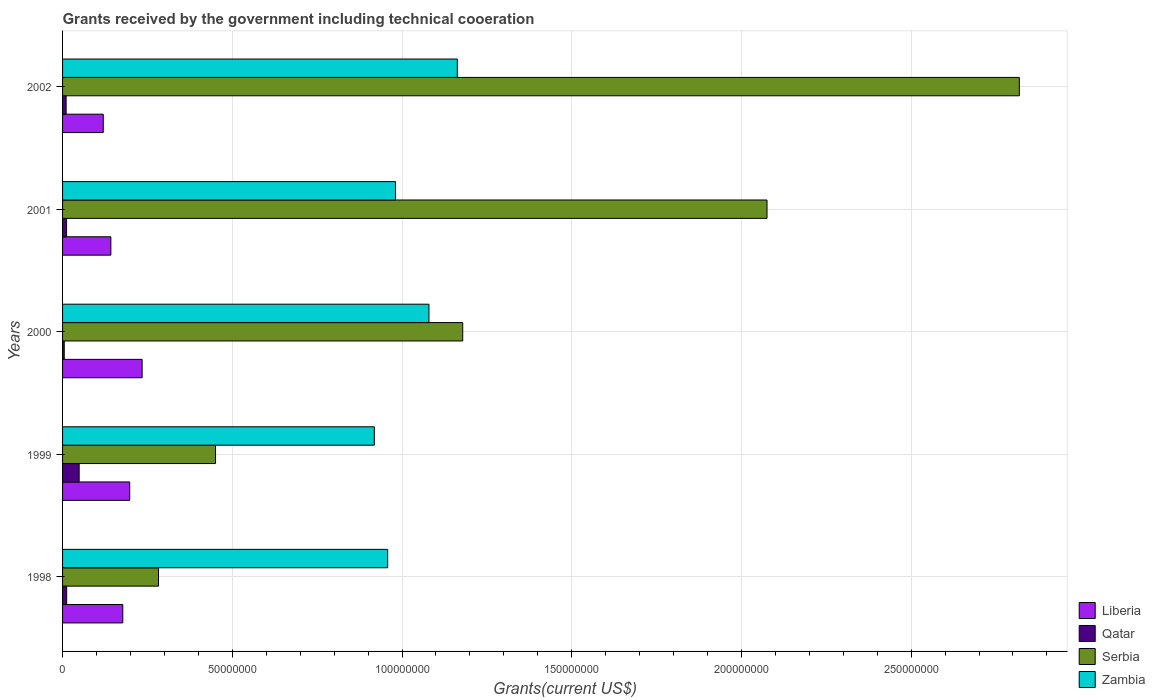How many groups of bars are there?
Your answer should be very brief. 5. Are the number of bars per tick equal to the number of legend labels?
Provide a short and direct response. Yes. How many bars are there on the 3rd tick from the top?
Offer a terse response. 4. How many bars are there on the 1st tick from the bottom?
Make the answer very short. 4. In how many cases, is the number of bars for a given year not equal to the number of legend labels?
Make the answer very short. 0. What is the total grants received by the government in Qatar in 1998?
Keep it short and to the point. 1.21e+06. Across all years, what is the maximum total grants received by the government in Qatar?
Make the answer very short. 4.89e+06. Across all years, what is the minimum total grants received by the government in Serbia?
Keep it short and to the point. 2.83e+07. In which year was the total grants received by the government in Zambia maximum?
Your answer should be compact. 2002. What is the total total grants received by the government in Serbia in the graph?
Keep it short and to the point. 6.81e+08. What is the difference between the total grants received by the government in Serbia in 1998 and that in 2002?
Ensure brevity in your answer.  -2.54e+08. What is the difference between the total grants received by the government in Qatar in 2001 and the total grants received by the government in Liberia in 2002?
Keep it short and to the point. -1.08e+07. What is the average total grants received by the government in Qatar per year?
Give a very brief answer. 1.76e+06. In the year 2000, what is the difference between the total grants received by the government in Serbia and total grants received by the government in Zambia?
Your response must be concise. 9.95e+06. In how many years, is the total grants received by the government in Zambia greater than 250000000 US$?
Offer a very short reply. 0. What is the ratio of the total grants received by the government in Qatar in 1998 to that in 2001?
Your answer should be compact. 1.03. Is the difference between the total grants received by the government in Serbia in 1999 and 2000 greater than the difference between the total grants received by the government in Zambia in 1999 and 2000?
Offer a terse response. No. What is the difference between the highest and the second highest total grants received by the government in Zambia?
Keep it short and to the point. 8.36e+06. What is the difference between the highest and the lowest total grants received by the government in Qatar?
Ensure brevity in your answer.  4.40e+06. Is it the case that in every year, the sum of the total grants received by the government in Qatar and total grants received by the government in Zambia is greater than the sum of total grants received by the government in Serbia and total grants received by the government in Liberia?
Ensure brevity in your answer.  No. What does the 3rd bar from the top in 1999 represents?
Provide a succinct answer. Qatar. What does the 2nd bar from the bottom in 2000 represents?
Make the answer very short. Qatar. How many bars are there?
Your answer should be compact. 20. How many years are there in the graph?
Your answer should be compact. 5. Are the values on the major ticks of X-axis written in scientific E-notation?
Make the answer very short. No. Does the graph contain grids?
Your answer should be very brief. Yes. Where does the legend appear in the graph?
Keep it short and to the point. Bottom right. How are the legend labels stacked?
Ensure brevity in your answer.  Vertical. What is the title of the graph?
Your answer should be very brief. Grants received by the government including technical cooeration. Does "Kazakhstan" appear as one of the legend labels in the graph?
Keep it short and to the point. No. What is the label or title of the X-axis?
Give a very brief answer. Grants(current US$). What is the Grants(current US$) of Liberia in 1998?
Provide a short and direct response. 1.77e+07. What is the Grants(current US$) in Qatar in 1998?
Keep it short and to the point. 1.21e+06. What is the Grants(current US$) in Serbia in 1998?
Offer a terse response. 2.83e+07. What is the Grants(current US$) in Zambia in 1998?
Offer a terse response. 9.58e+07. What is the Grants(current US$) in Liberia in 1999?
Your response must be concise. 1.98e+07. What is the Grants(current US$) in Qatar in 1999?
Your answer should be compact. 4.89e+06. What is the Grants(current US$) in Serbia in 1999?
Give a very brief answer. 4.51e+07. What is the Grants(current US$) in Zambia in 1999?
Give a very brief answer. 9.18e+07. What is the Grants(current US$) of Liberia in 2000?
Make the answer very short. 2.34e+07. What is the Grants(current US$) in Qatar in 2000?
Provide a succinct answer. 4.90e+05. What is the Grants(current US$) in Serbia in 2000?
Your response must be concise. 1.18e+08. What is the Grants(current US$) in Zambia in 2000?
Offer a terse response. 1.08e+08. What is the Grants(current US$) of Liberia in 2001?
Offer a terse response. 1.42e+07. What is the Grants(current US$) of Qatar in 2001?
Make the answer very short. 1.18e+06. What is the Grants(current US$) of Serbia in 2001?
Provide a short and direct response. 2.08e+08. What is the Grants(current US$) of Zambia in 2001?
Give a very brief answer. 9.81e+07. What is the Grants(current US$) in Liberia in 2002?
Ensure brevity in your answer.  1.20e+07. What is the Grants(current US$) in Qatar in 2002?
Offer a terse response. 1.05e+06. What is the Grants(current US$) in Serbia in 2002?
Your answer should be very brief. 2.82e+08. What is the Grants(current US$) of Zambia in 2002?
Your response must be concise. 1.16e+08. Across all years, what is the maximum Grants(current US$) in Liberia?
Provide a succinct answer. 2.34e+07. Across all years, what is the maximum Grants(current US$) in Qatar?
Provide a short and direct response. 4.89e+06. Across all years, what is the maximum Grants(current US$) in Serbia?
Your answer should be very brief. 2.82e+08. Across all years, what is the maximum Grants(current US$) in Zambia?
Your answer should be very brief. 1.16e+08. Across all years, what is the minimum Grants(current US$) of Liberia?
Provide a short and direct response. 1.20e+07. Across all years, what is the minimum Grants(current US$) of Serbia?
Provide a succinct answer. 2.83e+07. Across all years, what is the minimum Grants(current US$) in Zambia?
Give a very brief answer. 9.18e+07. What is the total Grants(current US$) in Liberia in the graph?
Offer a very short reply. 8.72e+07. What is the total Grants(current US$) in Qatar in the graph?
Give a very brief answer. 8.82e+06. What is the total Grants(current US$) in Serbia in the graph?
Offer a very short reply. 6.81e+08. What is the total Grants(current US$) in Zambia in the graph?
Keep it short and to the point. 5.10e+08. What is the difference between the Grants(current US$) of Liberia in 1998 and that in 1999?
Provide a short and direct response. -2.04e+06. What is the difference between the Grants(current US$) of Qatar in 1998 and that in 1999?
Provide a short and direct response. -3.68e+06. What is the difference between the Grants(current US$) in Serbia in 1998 and that in 1999?
Make the answer very short. -1.68e+07. What is the difference between the Grants(current US$) of Zambia in 1998 and that in 1999?
Give a very brief answer. 3.93e+06. What is the difference between the Grants(current US$) in Liberia in 1998 and that in 2000?
Make the answer very short. -5.70e+06. What is the difference between the Grants(current US$) in Qatar in 1998 and that in 2000?
Ensure brevity in your answer.  7.20e+05. What is the difference between the Grants(current US$) of Serbia in 1998 and that in 2000?
Offer a very short reply. -8.96e+07. What is the difference between the Grants(current US$) of Zambia in 1998 and that in 2000?
Your response must be concise. -1.22e+07. What is the difference between the Grants(current US$) in Liberia in 1998 and that in 2001?
Keep it short and to the point. 3.51e+06. What is the difference between the Grants(current US$) in Serbia in 1998 and that in 2001?
Offer a very short reply. -1.79e+08. What is the difference between the Grants(current US$) in Zambia in 1998 and that in 2001?
Ensure brevity in your answer.  -2.31e+06. What is the difference between the Grants(current US$) in Liberia in 1998 and that in 2002?
Provide a short and direct response. 5.75e+06. What is the difference between the Grants(current US$) of Qatar in 1998 and that in 2002?
Give a very brief answer. 1.60e+05. What is the difference between the Grants(current US$) of Serbia in 1998 and that in 2002?
Your answer should be very brief. -2.54e+08. What is the difference between the Grants(current US$) in Zambia in 1998 and that in 2002?
Provide a short and direct response. -2.05e+07. What is the difference between the Grants(current US$) in Liberia in 1999 and that in 2000?
Your answer should be compact. -3.66e+06. What is the difference between the Grants(current US$) of Qatar in 1999 and that in 2000?
Provide a succinct answer. 4.40e+06. What is the difference between the Grants(current US$) of Serbia in 1999 and that in 2000?
Keep it short and to the point. -7.28e+07. What is the difference between the Grants(current US$) in Zambia in 1999 and that in 2000?
Offer a very short reply. -1.61e+07. What is the difference between the Grants(current US$) of Liberia in 1999 and that in 2001?
Keep it short and to the point. 5.55e+06. What is the difference between the Grants(current US$) of Qatar in 1999 and that in 2001?
Make the answer very short. 3.71e+06. What is the difference between the Grants(current US$) in Serbia in 1999 and that in 2001?
Provide a succinct answer. -1.62e+08. What is the difference between the Grants(current US$) in Zambia in 1999 and that in 2001?
Your response must be concise. -6.24e+06. What is the difference between the Grants(current US$) of Liberia in 1999 and that in 2002?
Provide a short and direct response. 7.79e+06. What is the difference between the Grants(current US$) of Qatar in 1999 and that in 2002?
Keep it short and to the point. 3.84e+06. What is the difference between the Grants(current US$) of Serbia in 1999 and that in 2002?
Your answer should be very brief. -2.37e+08. What is the difference between the Grants(current US$) of Zambia in 1999 and that in 2002?
Offer a very short reply. -2.44e+07. What is the difference between the Grants(current US$) in Liberia in 2000 and that in 2001?
Give a very brief answer. 9.21e+06. What is the difference between the Grants(current US$) of Qatar in 2000 and that in 2001?
Provide a short and direct response. -6.90e+05. What is the difference between the Grants(current US$) of Serbia in 2000 and that in 2001?
Ensure brevity in your answer.  -8.96e+07. What is the difference between the Grants(current US$) of Zambia in 2000 and that in 2001?
Offer a very short reply. 9.85e+06. What is the difference between the Grants(current US$) of Liberia in 2000 and that in 2002?
Provide a short and direct response. 1.14e+07. What is the difference between the Grants(current US$) of Qatar in 2000 and that in 2002?
Make the answer very short. -5.60e+05. What is the difference between the Grants(current US$) of Serbia in 2000 and that in 2002?
Provide a short and direct response. -1.64e+08. What is the difference between the Grants(current US$) in Zambia in 2000 and that in 2002?
Ensure brevity in your answer.  -8.36e+06. What is the difference between the Grants(current US$) of Liberia in 2001 and that in 2002?
Keep it short and to the point. 2.24e+06. What is the difference between the Grants(current US$) of Serbia in 2001 and that in 2002?
Offer a terse response. -7.43e+07. What is the difference between the Grants(current US$) of Zambia in 2001 and that in 2002?
Offer a terse response. -1.82e+07. What is the difference between the Grants(current US$) of Liberia in 1998 and the Grants(current US$) of Qatar in 1999?
Offer a terse response. 1.28e+07. What is the difference between the Grants(current US$) of Liberia in 1998 and the Grants(current US$) of Serbia in 1999?
Provide a short and direct response. -2.73e+07. What is the difference between the Grants(current US$) of Liberia in 1998 and the Grants(current US$) of Zambia in 1999?
Your answer should be very brief. -7.41e+07. What is the difference between the Grants(current US$) of Qatar in 1998 and the Grants(current US$) of Serbia in 1999?
Make the answer very short. -4.39e+07. What is the difference between the Grants(current US$) of Qatar in 1998 and the Grants(current US$) of Zambia in 1999?
Provide a short and direct response. -9.06e+07. What is the difference between the Grants(current US$) in Serbia in 1998 and the Grants(current US$) in Zambia in 1999?
Your response must be concise. -6.36e+07. What is the difference between the Grants(current US$) of Liberia in 1998 and the Grants(current US$) of Qatar in 2000?
Keep it short and to the point. 1.72e+07. What is the difference between the Grants(current US$) in Liberia in 1998 and the Grants(current US$) in Serbia in 2000?
Your response must be concise. -1.00e+08. What is the difference between the Grants(current US$) of Liberia in 1998 and the Grants(current US$) of Zambia in 2000?
Your answer should be compact. -9.02e+07. What is the difference between the Grants(current US$) in Qatar in 1998 and the Grants(current US$) in Serbia in 2000?
Provide a succinct answer. -1.17e+08. What is the difference between the Grants(current US$) of Qatar in 1998 and the Grants(current US$) of Zambia in 2000?
Your response must be concise. -1.07e+08. What is the difference between the Grants(current US$) in Serbia in 1998 and the Grants(current US$) in Zambia in 2000?
Offer a terse response. -7.97e+07. What is the difference between the Grants(current US$) of Liberia in 1998 and the Grants(current US$) of Qatar in 2001?
Your answer should be very brief. 1.66e+07. What is the difference between the Grants(current US$) in Liberia in 1998 and the Grants(current US$) in Serbia in 2001?
Keep it short and to the point. -1.90e+08. What is the difference between the Grants(current US$) of Liberia in 1998 and the Grants(current US$) of Zambia in 2001?
Your answer should be very brief. -8.04e+07. What is the difference between the Grants(current US$) of Qatar in 1998 and the Grants(current US$) of Serbia in 2001?
Your answer should be very brief. -2.06e+08. What is the difference between the Grants(current US$) of Qatar in 1998 and the Grants(current US$) of Zambia in 2001?
Ensure brevity in your answer.  -9.69e+07. What is the difference between the Grants(current US$) of Serbia in 1998 and the Grants(current US$) of Zambia in 2001?
Make the answer very short. -6.98e+07. What is the difference between the Grants(current US$) in Liberia in 1998 and the Grants(current US$) in Qatar in 2002?
Keep it short and to the point. 1.67e+07. What is the difference between the Grants(current US$) of Liberia in 1998 and the Grants(current US$) of Serbia in 2002?
Give a very brief answer. -2.64e+08. What is the difference between the Grants(current US$) in Liberia in 1998 and the Grants(current US$) in Zambia in 2002?
Give a very brief answer. -9.86e+07. What is the difference between the Grants(current US$) in Qatar in 1998 and the Grants(current US$) in Serbia in 2002?
Your answer should be compact. -2.81e+08. What is the difference between the Grants(current US$) in Qatar in 1998 and the Grants(current US$) in Zambia in 2002?
Your response must be concise. -1.15e+08. What is the difference between the Grants(current US$) in Serbia in 1998 and the Grants(current US$) in Zambia in 2002?
Provide a short and direct response. -8.80e+07. What is the difference between the Grants(current US$) in Liberia in 1999 and the Grants(current US$) in Qatar in 2000?
Provide a succinct answer. 1.93e+07. What is the difference between the Grants(current US$) in Liberia in 1999 and the Grants(current US$) in Serbia in 2000?
Provide a short and direct response. -9.81e+07. What is the difference between the Grants(current US$) in Liberia in 1999 and the Grants(current US$) in Zambia in 2000?
Offer a very short reply. -8.82e+07. What is the difference between the Grants(current US$) of Qatar in 1999 and the Grants(current US$) of Serbia in 2000?
Offer a terse response. -1.13e+08. What is the difference between the Grants(current US$) of Qatar in 1999 and the Grants(current US$) of Zambia in 2000?
Make the answer very short. -1.03e+08. What is the difference between the Grants(current US$) in Serbia in 1999 and the Grants(current US$) in Zambia in 2000?
Make the answer very short. -6.29e+07. What is the difference between the Grants(current US$) of Liberia in 1999 and the Grants(current US$) of Qatar in 2001?
Your answer should be very brief. 1.86e+07. What is the difference between the Grants(current US$) in Liberia in 1999 and the Grants(current US$) in Serbia in 2001?
Give a very brief answer. -1.88e+08. What is the difference between the Grants(current US$) in Liberia in 1999 and the Grants(current US$) in Zambia in 2001?
Your answer should be very brief. -7.83e+07. What is the difference between the Grants(current US$) in Qatar in 1999 and the Grants(current US$) in Serbia in 2001?
Offer a terse response. -2.03e+08. What is the difference between the Grants(current US$) in Qatar in 1999 and the Grants(current US$) in Zambia in 2001?
Your response must be concise. -9.32e+07. What is the difference between the Grants(current US$) of Serbia in 1999 and the Grants(current US$) of Zambia in 2001?
Keep it short and to the point. -5.30e+07. What is the difference between the Grants(current US$) in Liberia in 1999 and the Grants(current US$) in Qatar in 2002?
Your answer should be compact. 1.87e+07. What is the difference between the Grants(current US$) of Liberia in 1999 and the Grants(current US$) of Serbia in 2002?
Provide a succinct answer. -2.62e+08. What is the difference between the Grants(current US$) in Liberia in 1999 and the Grants(current US$) in Zambia in 2002?
Give a very brief answer. -9.65e+07. What is the difference between the Grants(current US$) of Qatar in 1999 and the Grants(current US$) of Serbia in 2002?
Offer a very short reply. -2.77e+08. What is the difference between the Grants(current US$) of Qatar in 1999 and the Grants(current US$) of Zambia in 2002?
Offer a very short reply. -1.11e+08. What is the difference between the Grants(current US$) in Serbia in 1999 and the Grants(current US$) in Zambia in 2002?
Offer a terse response. -7.12e+07. What is the difference between the Grants(current US$) of Liberia in 2000 and the Grants(current US$) of Qatar in 2001?
Your response must be concise. 2.23e+07. What is the difference between the Grants(current US$) of Liberia in 2000 and the Grants(current US$) of Serbia in 2001?
Offer a very short reply. -1.84e+08. What is the difference between the Grants(current US$) in Liberia in 2000 and the Grants(current US$) in Zambia in 2001?
Offer a very short reply. -7.46e+07. What is the difference between the Grants(current US$) in Qatar in 2000 and the Grants(current US$) in Serbia in 2001?
Your answer should be compact. -2.07e+08. What is the difference between the Grants(current US$) of Qatar in 2000 and the Grants(current US$) of Zambia in 2001?
Offer a terse response. -9.76e+07. What is the difference between the Grants(current US$) in Serbia in 2000 and the Grants(current US$) in Zambia in 2001?
Provide a short and direct response. 1.98e+07. What is the difference between the Grants(current US$) in Liberia in 2000 and the Grants(current US$) in Qatar in 2002?
Provide a succinct answer. 2.24e+07. What is the difference between the Grants(current US$) of Liberia in 2000 and the Grants(current US$) of Serbia in 2002?
Make the answer very short. -2.58e+08. What is the difference between the Grants(current US$) of Liberia in 2000 and the Grants(current US$) of Zambia in 2002?
Offer a very short reply. -9.29e+07. What is the difference between the Grants(current US$) of Qatar in 2000 and the Grants(current US$) of Serbia in 2002?
Ensure brevity in your answer.  -2.81e+08. What is the difference between the Grants(current US$) of Qatar in 2000 and the Grants(current US$) of Zambia in 2002?
Offer a very short reply. -1.16e+08. What is the difference between the Grants(current US$) in Serbia in 2000 and the Grants(current US$) in Zambia in 2002?
Keep it short and to the point. 1.59e+06. What is the difference between the Grants(current US$) of Liberia in 2001 and the Grants(current US$) of Qatar in 2002?
Make the answer very short. 1.32e+07. What is the difference between the Grants(current US$) in Liberia in 2001 and the Grants(current US$) in Serbia in 2002?
Your answer should be compact. -2.68e+08. What is the difference between the Grants(current US$) in Liberia in 2001 and the Grants(current US$) in Zambia in 2002?
Provide a short and direct response. -1.02e+08. What is the difference between the Grants(current US$) of Qatar in 2001 and the Grants(current US$) of Serbia in 2002?
Your answer should be very brief. -2.81e+08. What is the difference between the Grants(current US$) of Qatar in 2001 and the Grants(current US$) of Zambia in 2002?
Offer a terse response. -1.15e+08. What is the difference between the Grants(current US$) in Serbia in 2001 and the Grants(current US$) in Zambia in 2002?
Provide a short and direct response. 9.12e+07. What is the average Grants(current US$) in Liberia per year?
Your answer should be very brief. 1.74e+07. What is the average Grants(current US$) in Qatar per year?
Make the answer very short. 1.76e+06. What is the average Grants(current US$) of Serbia per year?
Make the answer very short. 1.36e+08. What is the average Grants(current US$) in Zambia per year?
Your answer should be compact. 1.02e+08. In the year 1998, what is the difference between the Grants(current US$) in Liberia and Grants(current US$) in Qatar?
Your response must be concise. 1.65e+07. In the year 1998, what is the difference between the Grants(current US$) in Liberia and Grants(current US$) in Serbia?
Keep it short and to the point. -1.05e+07. In the year 1998, what is the difference between the Grants(current US$) in Liberia and Grants(current US$) in Zambia?
Offer a very short reply. -7.80e+07. In the year 1998, what is the difference between the Grants(current US$) in Qatar and Grants(current US$) in Serbia?
Provide a short and direct response. -2.71e+07. In the year 1998, what is the difference between the Grants(current US$) in Qatar and Grants(current US$) in Zambia?
Your answer should be compact. -9.46e+07. In the year 1998, what is the difference between the Grants(current US$) of Serbia and Grants(current US$) of Zambia?
Provide a short and direct response. -6.75e+07. In the year 1999, what is the difference between the Grants(current US$) of Liberia and Grants(current US$) of Qatar?
Provide a short and direct response. 1.49e+07. In the year 1999, what is the difference between the Grants(current US$) of Liberia and Grants(current US$) of Serbia?
Keep it short and to the point. -2.53e+07. In the year 1999, what is the difference between the Grants(current US$) in Liberia and Grants(current US$) in Zambia?
Ensure brevity in your answer.  -7.21e+07. In the year 1999, what is the difference between the Grants(current US$) in Qatar and Grants(current US$) in Serbia?
Make the answer very short. -4.02e+07. In the year 1999, what is the difference between the Grants(current US$) in Qatar and Grants(current US$) in Zambia?
Keep it short and to the point. -8.70e+07. In the year 1999, what is the difference between the Grants(current US$) in Serbia and Grants(current US$) in Zambia?
Provide a succinct answer. -4.68e+07. In the year 2000, what is the difference between the Grants(current US$) in Liberia and Grants(current US$) in Qatar?
Make the answer very short. 2.30e+07. In the year 2000, what is the difference between the Grants(current US$) of Liberia and Grants(current US$) of Serbia?
Give a very brief answer. -9.44e+07. In the year 2000, what is the difference between the Grants(current US$) of Liberia and Grants(current US$) of Zambia?
Offer a terse response. -8.45e+07. In the year 2000, what is the difference between the Grants(current US$) in Qatar and Grants(current US$) in Serbia?
Offer a very short reply. -1.17e+08. In the year 2000, what is the difference between the Grants(current US$) in Qatar and Grants(current US$) in Zambia?
Ensure brevity in your answer.  -1.07e+08. In the year 2000, what is the difference between the Grants(current US$) in Serbia and Grants(current US$) in Zambia?
Your answer should be very brief. 9.95e+06. In the year 2001, what is the difference between the Grants(current US$) in Liberia and Grants(current US$) in Qatar?
Offer a very short reply. 1.30e+07. In the year 2001, what is the difference between the Grants(current US$) of Liberia and Grants(current US$) of Serbia?
Offer a very short reply. -1.93e+08. In the year 2001, what is the difference between the Grants(current US$) in Liberia and Grants(current US$) in Zambia?
Make the answer very short. -8.39e+07. In the year 2001, what is the difference between the Grants(current US$) of Qatar and Grants(current US$) of Serbia?
Your response must be concise. -2.06e+08. In the year 2001, what is the difference between the Grants(current US$) in Qatar and Grants(current US$) in Zambia?
Your answer should be compact. -9.69e+07. In the year 2001, what is the difference between the Grants(current US$) of Serbia and Grants(current US$) of Zambia?
Offer a terse response. 1.09e+08. In the year 2002, what is the difference between the Grants(current US$) of Liberia and Grants(current US$) of Qatar?
Offer a very short reply. 1.09e+07. In the year 2002, what is the difference between the Grants(current US$) in Liberia and Grants(current US$) in Serbia?
Keep it short and to the point. -2.70e+08. In the year 2002, what is the difference between the Grants(current US$) of Liberia and Grants(current US$) of Zambia?
Ensure brevity in your answer.  -1.04e+08. In the year 2002, what is the difference between the Grants(current US$) of Qatar and Grants(current US$) of Serbia?
Provide a succinct answer. -2.81e+08. In the year 2002, what is the difference between the Grants(current US$) of Qatar and Grants(current US$) of Zambia?
Keep it short and to the point. -1.15e+08. In the year 2002, what is the difference between the Grants(current US$) in Serbia and Grants(current US$) in Zambia?
Your response must be concise. 1.66e+08. What is the ratio of the Grants(current US$) in Liberia in 1998 to that in 1999?
Provide a short and direct response. 0.9. What is the ratio of the Grants(current US$) of Qatar in 1998 to that in 1999?
Provide a short and direct response. 0.25. What is the ratio of the Grants(current US$) in Serbia in 1998 to that in 1999?
Make the answer very short. 0.63. What is the ratio of the Grants(current US$) in Zambia in 1998 to that in 1999?
Provide a succinct answer. 1.04. What is the ratio of the Grants(current US$) in Liberia in 1998 to that in 2000?
Give a very brief answer. 0.76. What is the ratio of the Grants(current US$) of Qatar in 1998 to that in 2000?
Your answer should be very brief. 2.47. What is the ratio of the Grants(current US$) of Serbia in 1998 to that in 2000?
Ensure brevity in your answer.  0.24. What is the ratio of the Grants(current US$) of Zambia in 1998 to that in 2000?
Provide a succinct answer. 0.89. What is the ratio of the Grants(current US$) in Liberia in 1998 to that in 2001?
Keep it short and to the point. 1.25. What is the ratio of the Grants(current US$) in Qatar in 1998 to that in 2001?
Your answer should be compact. 1.03. What is the ratio of the Grants(current US$) of Serbia in 1998 to that in 2001?
Make the answer very short. 0.14. What is the ratio of the Grants(current US$) in Zambia in 1998 to that in 2001?
Offer a terse response. 0.98. What is the ratio of the Grants(current US$) of Liberia in 1998 to that in 2002?
Make the answer very short. 1.48. What is the ratio of the Grants(current US$) in Qatar in 1998 to that in 2002?
Give a very brief answer. 1.15. What is the ratio of the Grants(current US$) in Serbia in 1998 to that in 2002?
Provide a succinct answer. 0.1. What is the ratio of the Grants(current US$) in Zambia in 1998 to that in 2002?
Provide a short and direct response. 0.82. What is the ratio of the Grants(current US$) in Liberia in 1999 to that in 2000?
Provide a succinct answer. 0.84. What is the ratio of the Grants(current US$) of Qatar in 1999 to that in 2000?
Ensure brevity in your answer.  9.98. What is the ratio of the Grants(current US$) in Serbia in 1999 to that in 2000?
Offer a terse response. 0.38. What is the ratio of the Grants(current US$) of Zambia in 1999 to that in 2000?
Offer a terse response. 0.85. What is the ratio of the Grants(current US$) in Liberia in 1999 to that in 2001?
Give a very brief answer. 1.39. What is the ratio of the Grants(current US$) of Qatar in 1999 to that in 2001?
Offer a very short reply. 4.14. What is the ratio of the Grants(current US$) of Serbia in 1999 to that in 2001?
Give a very brief answer. 0.22. What is the ratio of the Grants(current US$) of Zambia in 1999 to that in 2001?
Give a very brief answer. 0.94. What is the ratio of the Grants(current US$) in Liberia in 1999 to that in 2002?
Provide a short and direct response. 1.65. What is the ratio of the Grants(current US$) of Qatar in 1999 to that in 2002?
Provide a short and direct response. 4.66. What is the ratio of the Grants(current US$) in Serbia in 1999 to that in 2002?
Your answer should be compact. 0.16. What is the ratio of the Grants(current US$) of Zambia in 1999 to that in 2002?
Ensure brevity in your answer.  0.79. What is the ratio of the Grants(current US$) of Liberia in 2000 to that in 2001?
Your response must be concise. 1.65. What is the ratio of the Grants(current US$) of Qatar in 2000 to that in 2001?
Your response must be concise. 0.42. What is the ratio of the Grants(current US$) in Serbia in 2000 to that in 2001?
Provide a short and direct response. 0.57. What is the ratio of the Grants(current US$) of Zambia in 2000 to that in 2001?
Ensure brevity in your answer.  1.1. What is the ratio of the Grants(current US$) in Liberia in 2000 to that in 2002?
Provide a short and direct response. 1.96. What is the ratio of the Grants(current US$) in Qatar in 2000 to that in 2002?
Offer a very short reply. 0.47. What is the ratio of the Grants(current US$) of Serbia in 2000 to that in 2002?
Offer a terse response. 0.42. What is the ratio of the Grants(current US$) of Zambia in 2000 to that in 2002?
Provide a succinct answer. 0.93. What is the ratio of the Grants(current US$) of Liberia in 2001 to that in 2002?
Offer a terse response. 1.19. What is the ratio of the Grants(current US$) of Qatar in 2001 to that in 2002?
Provide a short and direct response. 1.12. What is the ratio of the Grants(current US$) in Serbia in 2001 to that in 2002?
Provide a short and direct response. 0.74. What is the ratio of the Grants(current US$) in Zambia in 2001 to that in 2002?
Offer a very short reply. 0.84. What is the difference between the highest and the second highest Grants(current US$) in Liberia?
Provide a succinct answer. 3.66e+06. What is the difference between the highest and the second highest Grants(current US$) in Qatar?
Provide a short and direct response. 3.68e+06. What is the difference between the highest and the second highest Grants(current US$) in Serbia?
Offer a terse response. 7.43e+07. What is the difference between the highest and the second highest Grants(current US$) of Zambia?
Provide a short and direct response. 8.36e+06. What is the difference between the highest and the lowest Grants(current US$) in Liberia?
Your answer should be compact. 1.14e+07. What is the difference between the highest and the lowest Grants(current US$) of Qatar?
Provide a succinct answer. 4.40e+06. What is the difference between the highest and the lowest Grants(current US$) of Serbia?
Offer a very short reply. 2.54e+08. What is the difference between the highest and the lowest Grants(current US$) in Zambia?
Make the answer very short. 2.44e+07. 